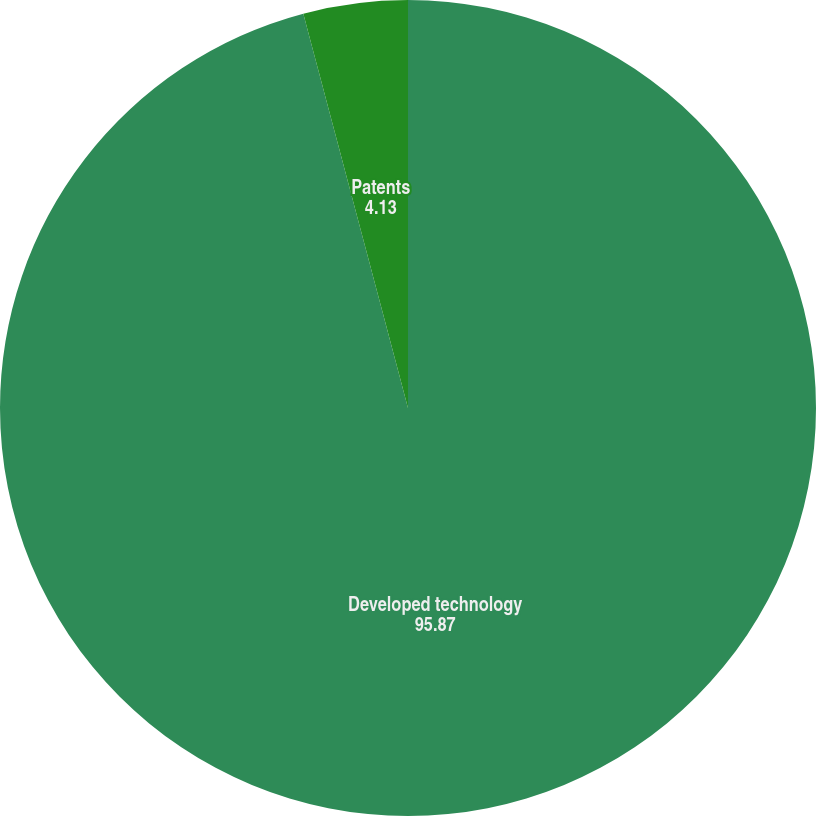<chart> <loc_0><loc_0><loc_500><loc_500><pie_chart><fcel>Developed technology<fcel>Patents<nl><fcel>95.87%<fcel>4.13%<nl></chart> 